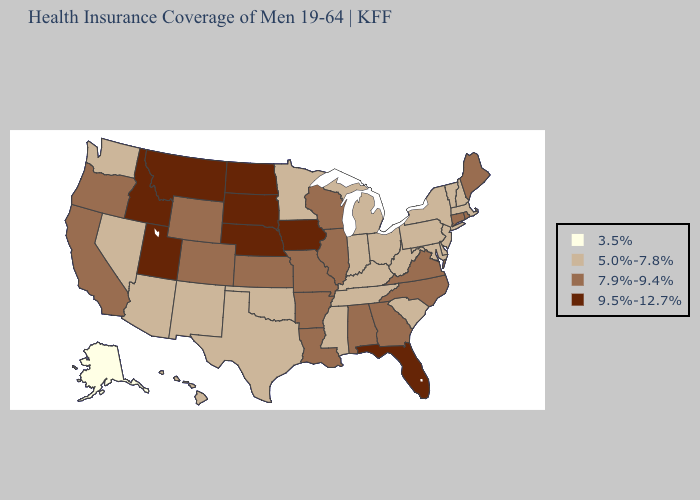Which states have the highest value in the USA?
Concise answer only. Florida, Idaho, Iowa, Montana, Nebraska, North Dakota, South Dakota, Utah. Does Hawaii have the highest value in the USA?
Keep it brief. No. Does the map have missing data?
Short answer required. No. Does Connecticut have the lowest value in the Northeast?
Keep it brief. No. What is the lowest value in states that border Arizona?
Write a very short answer. 5.0%-7.8%. What is the highest value in the Northeast ?
Answer briefly. 7.9%-9.4%. Name the states that have a value in the range 7.9%-9.4%?
Quick response, please. Alabama, Arkansas, California, Colorado, Connecticut, Georgia, Illinois, Kansas, Louisiana, Maine, Missouri, North Carolina, Oregon, Rhode Island, Virginia, Wisconsin, Wyoming. Name the states that have a value in the range 9.5%-12.7%?
Answer briefly. Florida, Idaho, Iowa, Montana, Nebraska, North Dakota, South Dakota, Utah. What is the value of New York?
Short answer required. 5.0%-7.8%. Name the states that have a value in the range 7.9%-9.4%?
Quick response, please. Alabama, Arkansas, California, Colorado, Connecticut, Georgia, Illinois, Kansas, Louisiana, Maine, Missouri, North Carolina, Oregon, Rhode Island, Virginia, Wisconsin, Wyoming. Does the map have missing data?
Give a very brief answer. No. What is the highest value in the USA?
Answer briefly. 9.5%-12.7%. Does the map have missing data?
Short answer required. No. Does Arizona have a higher value than California?
Quick response, please. No. Is the legend a continuous bar?
Be succinct. No. 